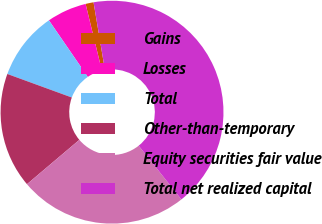Convert chart to OTSL. <chart><loc_0><loc_0><loc_500><loc_500><pie_chart><fcel>Gains<fcel>Losses<fcel>Total<fcel>Other-than-temporary<fcel>Equity securities fair value<fcel>Total net realized capital<nl><fcel>1.16%<fcel>5.77%<fcel>9.85%<fcel>16.75%<fcel>24.51%<fcel>41.97%<nl></chart> 